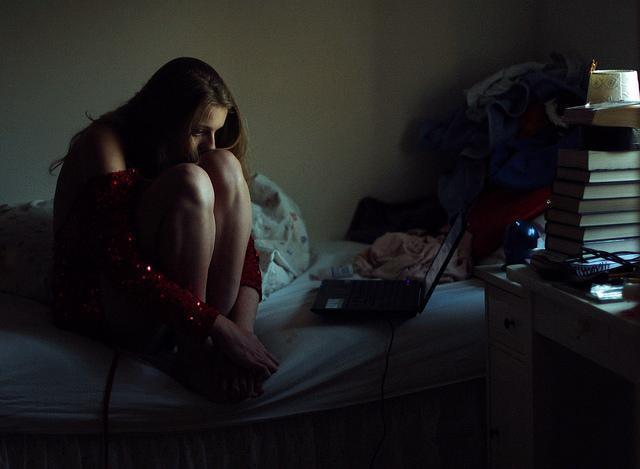How many computers are shown?
Give a very brief answer. 1. How many laptops are there?
Give a very brief answer. 1. 